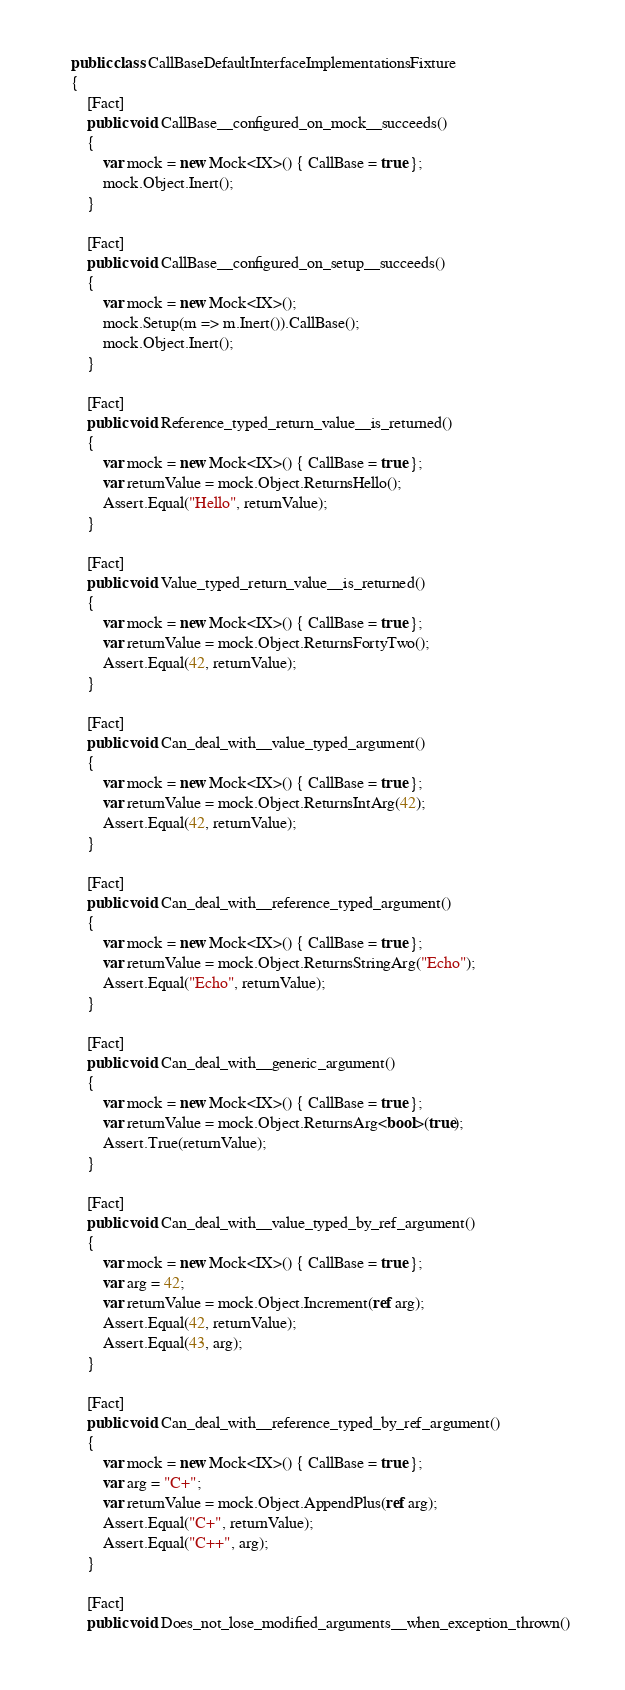Convert code to text. <code><loc_0><loc_0><loc_500><loc_500><_C#_>	public class CallBaseDefaultInterfaceImplementationsFixture
	{
		[Fact]
		public void CallBase__configured_on_mock__succeeds()
		{
			var mock = new Mock<IX>() { CallBase = true };
			mock.Object.Inert();
		}

		[Fact]
		public void CallBase__configured_on_setup__succeeds()
		{
			var mock = new Mock<IX>();
			mock.Setup(m => m.Inert()).CallBase();
			mock.Object.Inert();
		}

		[Fact]
		public void Reference_typed_return_value__is_returned()
		{
			var mock = new Mock<IX>() { CallBase = true };
			var returnValue = mock.Object.ReturnsHello();
			Assert.Equal("Hello", returnValue);
		}

		[Fact]
		public void Value_typed_return_value__is_returned()
		{
			var mock = new Mock<IX>() { CallBase = true };
			var returnValue = mock.Object.ReturnsFortyTwo();
			Assert.Equal(42, returnValue);
		}

		[Fact]
		public void Can_deal_with__value_typed_argument()
		{
			var mock = new Mock<IX>() { CallBase = true };
			var returnValue = mock.Object.ReturnsIntArg(42);
			Assert.Equal(42, returnValue);
		}

		[Fact]
		public void Can_deal_with__reference_typed_argument()
		{
			var mock = new Mock<IX>() { CallBase = true };
			var returnValue = mock.Object.ReturnsStringArg("Echo");
			Assert.Equal("Echo", returnValue);
		}

		[Fact]
		public void Can_deal_with__generic_argument()
		{
			var mock = new Mock<IX>() { CallBase = true };
			var returnValue = mock.Object.ReturnsArg<bool>(true);
			Assert.True(returnValue);
		}

		[Fact]
		public void Can_deal_with__value_typed_by_ref_argument()
		{
			var mock = new Mock<IX>() { CallBase = true };
			var arg = 42;
			var returnValue = mock.Object.Increment(ref arg);
			Assert.Equal(42, returnValue);
			Assert.Equal(43, arg);
		}

		[Fact]
		public void Can_deal_with__reference_typed_by_ref_argument()
		{
			var mock = new Mock<IX>() { CallBase = true };
			var arg = "C+";
			var returnValue = mock.Object.AppendPlus(ref arg);
			Assert.Equal("C+", returnValue);
			Assert.Equal("C++", arg);
		}

		[Fact]
		public void Does_not_lose_modified_arguments__when_exception_thrown()</code> 